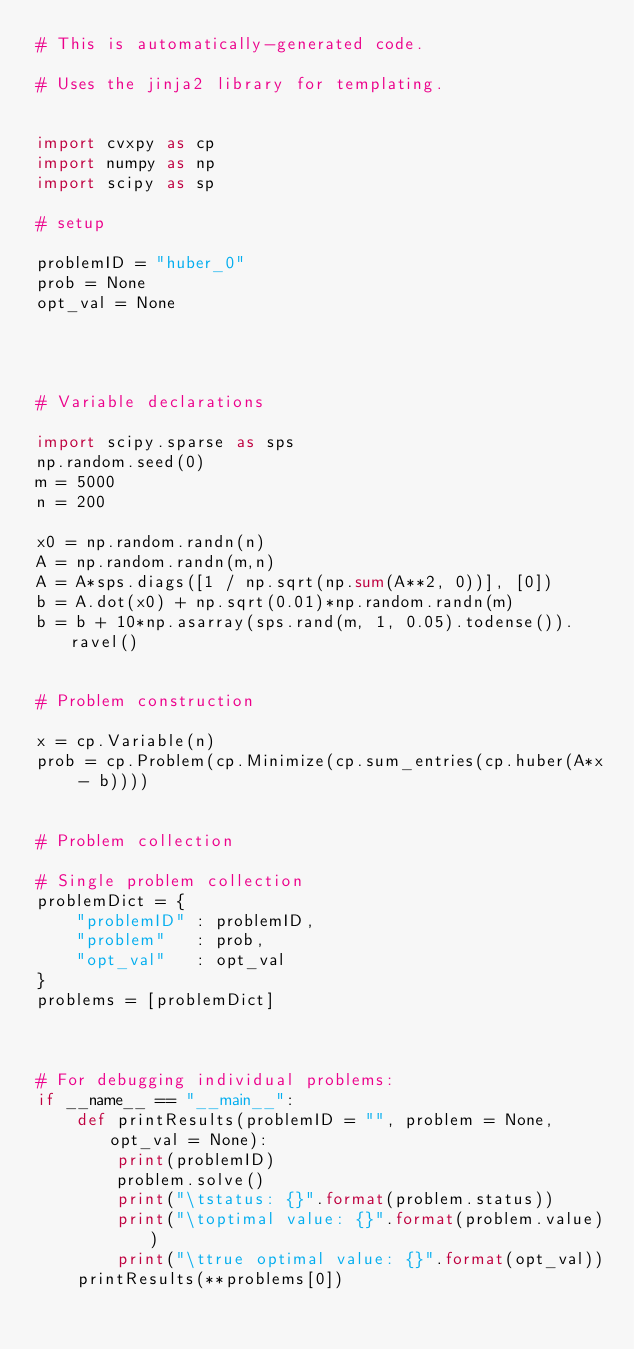Convert code to text. <code><loc_0><loc_0><loc_500><loc_500><_Python_># This is automatically-generated code.

# Uses the jinja2 library for templating.


import cvxpy as cp
import numpy as np
import scipy as sp

# setup

problemID = "huber_0"
prob = None
opt_val = None




# Variable declarations

import scipy.sparse as sps
np.random.seed(0)
m = 5000
n = 200

x0 = np.random.randn(n)
A = np.random.randn(m,n)
A = A*sps.diags([1 / np.sqrt(np.sum(A**2, 0))], [0])
b = A.dot(x0) + np.sqrt(0.01)*np.random.randn(m)
b = b + 10*np.asarray(sps.rand(m, 1, 0.05).todense()).ravel()


# Problem construction

x = cp.Variable(n)
prob = cp.Problem(cp.Minimize(cp.sum_entries(cp.huber(A*x - b))))


# Problem collection

# Single problem collection
problemDict = {
    "problemID" : problemID,
    "problem"   : prob,
    "opt_val"   : opt_val
}
problems = [problemDict]



# For debugging individual problems:
if __name__ == "__main__":
    def printResults(problemID = "", problem = None, opt_val = None):
        print(problemID)
        problem.solve()
        print("\tstatus: {}".format(problem.status))
        print("\toptimal value: {}".format(problem.value))
        print("\ttrue optimal value: {}".format(opt_val))
    printResults(**problems[0])


</code> 